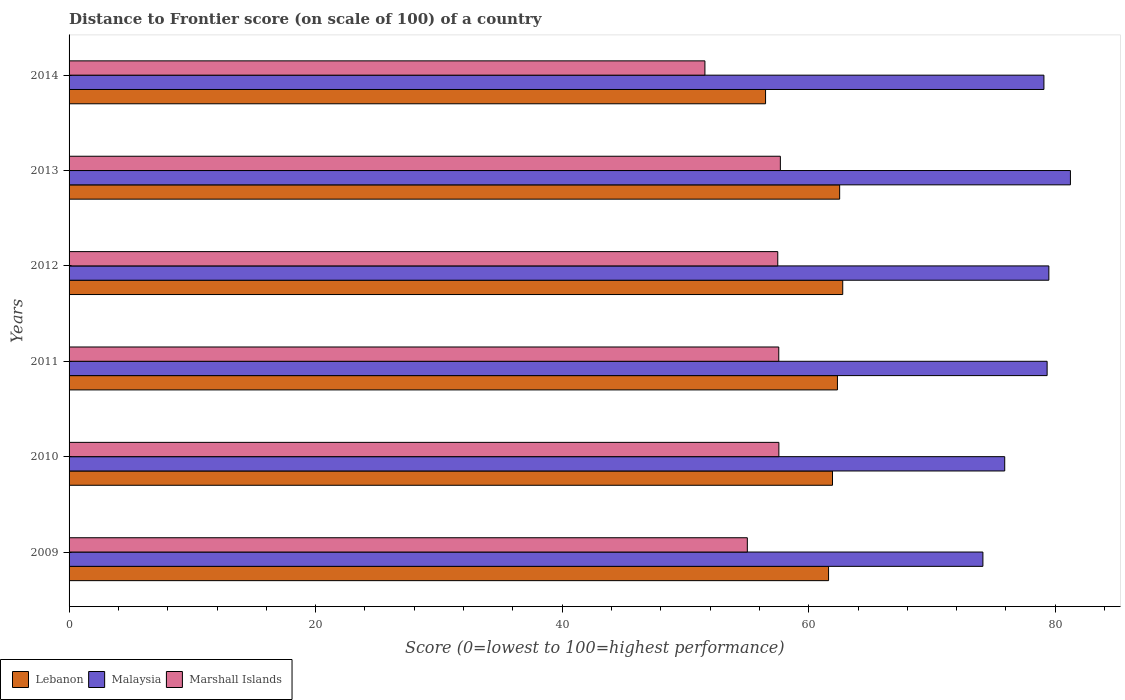How many different coloured bars are there?
Provide a short and direct response. 3. How many groups of bars are there?
Your answer should be compact. 6. Are the number of bars on each tick of the Y-axis equal?
Give a very brief answer. Yes. How many bars are there on the 3rd tick from the top?
Make the answer very short. 3. How many bars are there on the 6th tick from the bottom?
Keep it short and to the point. 3. In how many cases, is the number of bars for a given year not equal to the number of legend labels?
Provide a succinct answer. 0. What is the distance to frontier score of in Lebanon in 2011?
Your response must be concise. 62.33. Across all years, what is the maximum distance to frontier score of in Lebanon?
Offer a very short reply. 62.76. Across all years, what is the minimum distance to frontier score of in Marshall Islands?
Your answer should be very brief. 51.58. In which year was the distance to frontier score of in Malaysia maximum?
Make the answer very short. 2013. What is the total distance to frontier score of in Marshall Islands in the graph?
Provide a short and direct response. 336.94. What is the difference between the distance to frontier score of in Marshall Islands in 2009 and that in 2010?
Provide a short and direct response. -2.56. What is the difference between the distance to frontier score of in Lebanon in 2010 and the distance to frontier score of in Marshall Islands in 2011?
Offer a terse response. 4.36. What is the average distance to frontier score of in Marshall Islands per year?
Make the answer very short. 56.16. In the year 2011, what is the difference between the distance to frontier score of in Lebanon and distance to frontier score of in Malaysia?
Your answer should be compact. -17.01. What is the ratio of the distance to frontier score of in Marshall Islands in 2013 to that in 2014?
Provide a succinct answer. 1.12. Is the distance to frontier score of in Marshall Islands in 2009 less than that in 2010?
Give a very brief answer. Yes. What is the difference between the highest and the lowest distance to frontier score of in Malaysia?
Make the answer very short. 7.1. Is the sum of the distance to frontier score of in Marshall Islands in 2011 and 2013 greater than the maximum distance to frontier score of in Malaysia across all years?
Offer a terse response. Yes. What does the 3rd bar from the top in 2009 represents?
Offer a terse response. Lebanon. What does the 1st bar from the bottom in 2010 represents?
Offer a terse response. Lebanon. How many bars are there?
Provide a short and direct response. 18. Are all the bars in the graph horizontal?
Give a very brief answer. Yes. What is the difference between two consecutive major ticks on the X-axis?
Offer a very short reply. 20. Are the values on the major ticks of X-axis written in scientific E-notation?
Your response must be concise. No. Does the graph contain any zero values?
Ensure brevity in your answer.  No. Does the graph contain grids?
Ensure brevity in your answer.  No. How are the legend labels stacked?
Ensure brevity in your answer.  Horizontal. What is the title of the graph?
Ensure brevity in your answer.  Distance to Frontier score (on scale of 100) of a country. Does "St. Lucia" appear as one of the legend labels in the graph?
Your answer should be compact. No. What is the label or title of the X-axis?
Make the answer very short. Score (0=lowest to 100=highest performance). What is the label or title of the Y-axis?
Provide a succinct answer. Years. What is the Score (0=lowest to 100=highest performance) of Lebanon in 2009?
Give a very brief answer. 61.61. What is the Score (0=lowest to 100=highest performance) in Malaysia in 2009?
Your answer should be compact. 74.13. What is the Score (0=lowest to 100=highest performance) in Marshall Islands in 2009?
Your answer should be compact. 55.02. What is the Score (0=lowest to 100=highest performance) in Lebanon in 2010?
Your response must be concise. 61.93. What is the Score (0=lowest to 100=highest performance) of Malaysia in 2010?
Your answer should be very brief. 75.9. What is the Score (0=lowest to 100=highest performance) of Marshall Islands in 2010?
Keep it short and to the point. 57.58. What is the Score (0=lowest to 100=highest performance) of Lebanon in 2011?
Make the answer very short. 62.33. What is the Score (0=lowest to 100=highest performance) of Malaysia in 2011?
Your answer should be compact. 79.34. What is the Score (0=lowest to 100=highest performance) in Marshall Islands in 2011?
Ensure brevity in your answer.  57.57. What is the Score (0=lowest to 100=highest performance) in Lebanon in 2012?
Your response must be concise. 62.76. What is the Score (0=lowest to 100=highest performance) of Malaysia in 2012?
Keep it short and to the point. 79.48. What is the Score (0=lowest to 100=highest performance) in Marshall Islands in 2012?
Make the answer very short. 57.49. What is the Score (0=lowest to 100=highest performance) in Lebanon in 2013?
Your response must be concise. 62.51. What is the Score (0=lowest to 100=highest performance) in Malaysia in 2013?
Provide a succinct answer. 81.23. What is the Score (0=lowest to 100=highest performance) of Marshall Islands in 2013?
Your answer should be compact. 57.7. What is the Score (0=lowest to 100=highest performance) in Lebanon in 2014?
Make the answer very short. 56.5. What is the Score (0=lowest to 100=highest performance) in Malaysia in 2014?
Offer a terse response. 79.08. What is the Score (0=lowest to 100=highest performance) of Marshall Islands in 2014?
Your response must be concise. 51.58. Across all years, what is the maximum Score (0=lowest to 100=highest performance) of Lebanon?
Give a very brief answer. 62.76. Across all years, what is the maximum Score (0=lowest to 100=highest performance) of Malaysia?
Provide a succinct answer. 81.23. Across all years, what is the maximum Score (0=lowest to 100=highest performance) in Marshall Islands?
Provide a short and direct response. 57.7. Across all years, what is the minimum Score (0=lowest to 100=highest performance) in Lebanon?
Make the answer very short. 56.5. Across all years, what is the minimum Score (0=lowest to 100=highest performance) in Malaysia?
Keep it short and to the point. 74.13. Across all years, what is the minimum Score (0=lowest to 100=highest performance) in Marshall Islands?
Offer a very short reply. 51.58. What is the total Score (0=lowest to 100=highest performance) of Lebanon in the graph?
Give a very brief answer. 367.64. What is the total Score (0=lowest to 100=highest performance) in Malaysia in the graph?
Keep it short and to the point. 469.16. What is the total Score (0=lowest to 100=highest performance) in Marshall Islands in the graph?
Offer a very short reply. 336.94. What is the difference between the Score (0=lowest to 100=highest performance) of Lebanon in 2009 and that in 2010?
Ensure brevity in your answer.  -0.32. What is the difference between the Score (0=lowest to 100=highest performance) of Malaysia in 2009 and that in 2010?
Ensure brevity in your answer.  -1.77. What is the difference between the Score (0=lowest to 100=highest performance) in Marshall Islands in 2009 and that in 2010?
Ensure brevity in your answer.  -2.56. What is the difference between the Score (0=lowest to 100=highest performance) of Lebanon in 2009 and that in 2011?
Ensure brevity in your answer.  -0.72. What is the difference between the Score (0=lowest to 100=highest performance) in Malaysia in 2009 and that in 2011?
Ensure brevity in your answer.  -5.21. What is the difference between the Score (0=lowest to 100=highest performance) in Marshall Islands in 2009 and that in 2011?
Keep it short and to the point. -2.55. What is the difference between the Score (0=lowest to 100=highest performance) of Lebanon in 2009 and that in 2012?
Provide a short and direct response. -1.15. What is the difference between the Score (0=lowest to 100=highest performance) of Malaysia in 2009 and that in 2012?
Give a very brief answer. -5.35. What is the difference between the Score (0=lowest to 100=highest performance) in Marshall Islands in 2009 and that in 2012?
Offer a very short reply. -2.47. What is the difference between the Score (0=lowest to 100=highest performance) of Lebanon in 2009 and that in 2013?
Offer a very short reply. -0.9. What is the difference between the Score (0=lowest to 100=highest performance) of Marshall Islands in 2009 and that in 2013?
Offer a terse response. -2.68. What is the difference between the Score (0=lowest to 100=highest performance) of Lebanon in 2009 and that in 2014?
Provide a short and direct response. 5.11. What is the difference between the Score (0=lowest to 100=highest performance) of Malaysia in 2009 and that in 2014?
Make the answer very short. -4.95. What is the difference between the Score (0=lowest to 100=highest performance) of Marshall Islands in 2009 and that in 2014?
Your response must be concise. 3.44. What is the difference between the Score (0=lowest to 100=highest performance) of Malaysia in 2010 and that in 2011?
Provide a short and direct response. -3.44. What is the difference between the Score (0=lowest to 100=highest performance) of Marshall Islands in 2010 and that in 2011?
Your response must be concise. 0.01. What is the difference between the Score (0=lowest to 100=highest performance) in Lebanon in 2010 and that in 2012?
Offer a terse response. -0.83. What is the difference between the Score (0=lowest to 100=highest performance) in Malaysia in 2010 and that in 2012?
Give a very brief answer. -3.58. What is the difference between the Score (0=lowest to 100=highest performance) of Marshall Islands in 2010 and that in 2012?
Your answer should be very brief. 0.09. What is the difference between the Score (0=lowest to 100=highest performance) in Lebanon in 2010 and that in 2013?
Offer a terse response. -0.58. What is the difference between the Score (0=lowest to 100=highest performance) in Malaysia in 2010 and that in 2013?
Provide a succinct answer. -5.33. What is the difference between the Score (0=lowest to 100=highest performance) of Marshall Islands in 2010 and that in 2013?
Your answer should be compact. -0.12. What is the difference between the Score (0=lowest to 100=highest performance) in Lebanon in 2010 and that in 2014?
Provide a short and direct response. 5.43. What is the difference between the Score (0=lowest to 100=highest performance) in Malaysia in 2010 and that in 2014?
Provide a short and direct response. -3.18. What is the difference between the Score (0=lowest to 100=highest performance) in Marshall Islands in 2010 and that in 2014?
Provide a succinct answer. 6. What is the difference between the Score (0=lowest to 100=highest performance) in Lebanon in 2011 and that in 2012?
Offer a terse response. -0.43. What is the difference between the Score (0=lowest to 100=highest performance) of Malaysia in 2011 and that in 2012?
Your answer should be very brief. -0.14. What is the difference between the Score (0=lowest to 100=highest performance) in Marshall Islands in 2011 and that in 2012?
Your answer should be very brief. 0.08. What is the difference between the Score (0=lowest to 100=highest performance) of Lebanon in 2011 and that in 2013?
Your answer should be compact. -0.18. What is the difference between the Score (0=lowest to 100=highest performance) in Malaysia in 2011 and that in 2013?
Your answer should be very brief. -1.89. What is the difference between the Score (0=lowest to 100=highest performance) in Marshall Islands in 2011 and that in 2013?
Give a very brief answer. -0.13. What is the difference between the Score (0=lowest to 100=highest performance) in Lebanon in 2011 and that in 2014?
Give a very brief answer. 5.83. What is the difference between the Score (0=lowest to 100=highest performance) of Malaysia in 2011 and that in 2014?
Make the answer very short. 0.26. What is the difference between the Score (0=lowest to 100=highest performance) in Marshall Islands in 2011 and that in 2014?
Your answer should be compact. 5.99. What is the difference between the Score (0=lowest to 100=highest performance) in Lebanon in 2012 and that in 2013?
Keep it short and to the point. 0.25. What is the difference between the Score (0=lowest to 100=highest performance) of Malaysia in 2012 and that in 2013?
Provide a succinct answer. -1.75. What is the difference between the Score (0=lowest to 100=highest performance) of Marshall Islands in 2012 and that in 2013?
Your response must be concise. -0.21. What is the difference between the Score (0=lowest to 100=highest performance) of Lebanon in 2012 and that in 2014?
Provide a short and direct response. 6.26. What is the difference between the Score (0=lowest to 100=highest performance) of Marshall Islands in 2012 and that in 2014?
Your answer should be compact. 5.91. What is the difference between the Score (0=lowest to 100=highest performance) of Lebanon in 2013 and that in 2014?
Provide a succinct answer. 6.01. What is the difference between the Score (0=lowest to 100=highest performance) in Malaysia in 2013 and that in 2014?
Give a very brief answer. 2.15. What is the difference between the Score (0=lowest to 100=highest performance) in Marshall Islands in 2013 and that in 2014?
Offer a terse response. 6.12. What is the difference between the Score (0=lowest to 100=highest performance) in Lebanon in 2009 and the Score (0=lowest to 100=highest performance) in Malaysia in 2010?
Offer a terse response. -14.29. What is the difference between the Score (0=lowest to 100=highest performance) of Lebanon in 2009 and the Score (0=lowest to 100=highest performance) of Marshall Islands in 2010?
Ensure brevity in your answer.  4.03. What is the difference between the Score (0=lowest to 100=highest performance) of Malaysia in 2009 and the Score (0=lowest to 100=highest performance) of Marshall Islands in 2010?
Provide a succinct answer. 16.55. What is the difference between the Score (0=lowest to 100=highest performance) in Lebanon in 2009 and the Score (0=lowest to 100=highest performance) in Malaysia in 2011?
Your answer should be very brief. -17.73. What is the difference between the Score (0=lowest to 100=highest performance) in Lebanon in 2009 and the Score (0=lowest to 100=highest performance) in Marshall Islands in 2011?
Give a very brief answer. 4.04. What is the difference between the Score (0=lowest to 100=highest performance) of Malaysia in 2009 and the Score (0=lowest to 100=highest performance) of Marshall Islands in 2011?
Provide a succinct answer. 16.56. What is the difference between the Score (0=lowest to 100=highest performance) of Lebanon in 2009 and the Score (0=lowest to 100=highest performance) of Malaysia in 2012?
Keep it short and to the point. -17.87. What is the difference between the Score (0=lowest to 100=highest performance) of Lebanon in 2009 and the Score (0=lowest to 100=highest performance) of Marshall Islands in 2012?
Ensure brevity in your answer.  4.12. What is the difference between the Score (0=lowest to 100=highest performance) in Malaysia in 2009 and the Score (0=lowest to 100=highest performance) in Marshall Islands in 2012?
Offer a very short reply. 16.64. What is the difference between the Score (0=lowest to 100=highest performance) of Lebanon in 2009 and the Score (0=lowest to 100=highest performance) of Malaysia in 2013?
Your response must be concise. -19.62. What is the difference between the Score (0=lowest to 100=highest performance) of Lebanon in 2009 and the Score (0=lowest to 100=highest performance) of Marshall Islands in 2013?
Your answer should be very brief. 3.91. What is the difference between the Score (0=lowest to 100=highest performance) of Malaysia in 2009 and the Score (0=lowest to 100=highest performance) of Marshall Islands in 2013?
Your answer should be compact. 16.43. What is the difference between the Score (0=lowest to 100=highest performance) in Lebanon in 2009 and the Score (0=lowest to 100=highest performance) in Malaysia in 2014?
Offer a terse response. -17.47. What is the difference between the Score (0=lowest to 100=highest performance) in Lebanon in 2009 and the Score (0=lowest to 100=highest performance) in Marshall Islands in 2014?
Provide a succinct answer. 10.03. What is the difference between the Score (0=lowest to 100=highest performance) of Malaysia in 2009 and the Score (0=lowest to 100=highest performance) of Marshall Islands in 2014?
Your response must be concise. 22.55. What is the difference between the Score (0=lowest to 100=highest performance) in Lebanon in 2010 and the Score (0=lowest to 100=highest performance) in Malaysia in 2011?
Your answer should be very brief. -17.41. What is the difference between the Score (0=lowest to 100=highest performance) in Lebanon in 2010 and the Score (0=lowest to 100=highest performance) in Marshall Islands in 2011?
Provide a succinct answer. 4.36. What is the difference between the Score (0=lowest to 100=highest performance) of Malaysia in 2010 and the Score (0=lowest to 100=highest performance) of Marshall Islands in 2011?
Your response must be concise. 18.33. What is the difference between the Score (0=lowest to 100=highest performance) of Lebanon in 2010 and the Score (0=lowest to 100=highest performance) of Malaysia in 2012?
Provide a short and direct response. -17.55. What is the difference between the Score (0=lowest to 100=highest performance) of Lebanon in 2010 and the Score (0=lowest to 100=highest performance) of Marshall Islands in 2012?
Offer a very short reply. 4.44. What is the difference between the Score (0=lowest to 100=highest performance) of Malaysia in 2010 and the Score (0=lowest to 100=highest performance) of Marshall Islands in 2012?
Keep it short and to the point. 18.41. What is the difference between the Score (0=lowest to 100=highest performance) of Lebanon in 2010 and the Score (0=lowest to 100=highest performance) of Malaysia in 2013?
Your answer should be compact. -19.3. What is the difference between the Score (0=lowest to 100=highest performance) in Lebanon in 2010 and the Score (0=lowest to 100=highest performance) in Marshall Islands in 2013?
Provide a succinct answer. 4.23. What is the difference between the Score (0=lowest to 100=highest performance) in Malaysia in 2010 and the Score (0=lowest to 100=highest performance) in Marshall Islands in 2013?
Provide a succinct answer. 18.2. What is the difference between the Score (0=lowest to 100=highest performance) of Lebanon in 2010 and the Score (0=lowest to 100=highest performance) of Malaysia in 2014?
Your answer should be very brief. -17.15. What is the difference between the Score (0=lowest to 100=highest performance) of Lebanon in 2010 and the Score (0=lowest to 100=highest performance) of Marshall Islands in 2014?
Offer a terse response. 10.35. What is the difference between the Score (0=lowest to 100=highest performance) of Malaysia in 2010 and the Score (0=lowest to 100=highest performance) of Marshall Islands in 2014?
Provide a short and direct response. 24.32. What is the difference between the Score (0=lowest to 100=highest performance) of Lebanon in 2011 and the Score (0=lowest to 100=highest performance) of Malaysia in 2012?
Your answer should be compact. -17.15. What is the difference between the Score (0=lowest to 100=highest performance) of Lebanon in 2011 and the Score (0=lowest to 100=highest performance) of Marshall Islands in 2012?
Ensure brevity in your answer.  4.84. What is the difference between the Score (0=lowest to 100=highest performance) of Malaysia in 2011 and the Score (0=lowest to 100=highest performance) of Marshall Islands in 2012?
Offer a very short reply. 21.85. What is the difference between the Score (0=lowest to 100=highest performance) in Lebanon in 2011 and the Score (0=lowest to 100=highest performance) in Malaysia in 2013?
Your answer should be very brief. -18.9. What is the difference between the Score (0=lowest to 100=highest performance) of Lebanon in 2011 and the Score (0=lowest to 100=highest performance) of Marshall Islands in 2013?
Make the answer very short. 4.63. What is the difference between the Score (0=lowest to 100=highest performance) in Malaysia in 2011 and the Score (0=lowest to 100=highest performance) in Marshall Islands in 2013?
Your answer should be compact. 21.64. What is the difference between the Score (0=lowest to 100=highest performance) in Lebanon in 2011 and the Score (0=lowest to 100=highest performance) in Malaysia in 2014?
Offer a very short reply. -16.75. What is the difference between the Score (0=lowest to 100=highest performance) in Lebanon in 2011 and the Score (0=lowest to 100=highest performance) in Marshall Islands in 2014?
Make the answer very short. 10.75. What is the difference between the Score (0=lowest to 100=highest performance) of Malaysia in 2011 and the Score (0=lowest to 100=highest performance) of Marshall Islands in 2014?
Offer a very short reply. 27.76. What is the difference between the Score (0=lowest to 100=highest performance) in Lebanon in 2012 and the Score (0=lowest to 100=highest performance) in Malaysia in 2013?
Your response must be concise. -18.47. What is the difference between the Score (0=lowest to 100=highest performance) of Lebanon in 2012 and the Score (0=lowest to 100=highest performance) of Marshall Islands in 2013?
Make the answer very short. 5.06. What is the difference between the Score (0=lowest to 100=highest performance) of Malaysia in 2012 and the Score (0=lowest to 100=highest performance) of Marshall Islands in 2013?
Give a very brief answer. 21.78. What is the difference between the Score (0=lowest to 100=highest performance) of Lebanon in 2012 and the Score (0=lowest to 100=highest performance) of Malaysia in 2014?
Ensure brevity in your answer.  -16.32. What is the difference between the Score (0=lowest to 100=highest performance) of Lebanon in 2012 and the Score (0=lowest to 100=highest performance) of Marshall Islands in 2014?
Provide a succinct answer. 11.18. What is the difference between the Score (0=lowest to 100=highest performance) in Malaysia in 2012 and the Score (0=lowest to 100=highest performance) in Marshall Islands in 2014?
Provide a succinct answer. 27.9. What is the difference between the Score (0=lowest to 100=highest performance) of Lebanon in 2013 and the Score (0=lowest to 100=highest performance) of Malaysia in 2014?
Your answer should be very brief. -16.57. What is the difference between the Score (0=lowest to 100=highest performance) of Lebanon in 2013 and the Score (0=lowest to 100=highest performance) of Marshall Islands in 2014?
Your answer should be compact. 10.93. What is the difference between the Score (0=lowest to 100=highest performance) of Malaysia in 2013 and the Score (0=lowest to 100=highest performance) of Marshall Islands in 2014?
Give a very brief answer. 29.65. What is the average Score (0=lowest to 100=highest performance) in Lebanon per year?
Keep it short and to the point. 61.27. What is the average Score (0=lowest to 100=highest performance) of Malaysia per year?
Offer a terse response. 78.19. What is the average Score (0=lowest to 100=highest performance) in Marshall Islands per year?
Give a very brief answer. 56.16. In the year 2009, what is the difference between the Score (0=lowest to 100=highest performance) in Lebanon and Score (0=lowest to 100=highest performance) in Malaysia?
Provide a succinct answer. -12.52. In the year 2009, what is the difference between the Score (0=lowest to 100=highest performance) of Lebanon and Score (0=lowest to 100=highest performance) of Marshall Islands?
Keep it short and to the point. 6.59. In the year 2009, what is the difference between the Score (0=lowest to 100=highest performance) in Malaysia and Score (0=lowest to 100=highest performance) in Marshall Islands?
Your answer should be very brief. 19.11. In the year 2010, what is the difference between the Score (0=lowest to 100=highest performance) of Lebanon and Score (0=lowest to 100=highest performance) of Malaysia?
Offer a terse response. -13.97. In the year 2010, what is the difference between the Score (0=lowest to 100=highest performance) in Lebanon and Score (0=lowest to 100=highest performance) in Marshall Islands?
Give a very brief answer. 4.35. In the year 2010, what is the difference between the Score (0=lowest to 100=highest performance) in Malaysia and Score (0=lowest to 100=highest performance) in Marshall Islands?
Offer a terse response. 18.32. In the year 2011, what is the difference between the Score (0=lowest to 100=highest performance) of Lebanon and Score (0=lowest to 100=highest performance) of Malaysia?
Ensure brevity in your answer.  -17.01. In the year 2011, what is the difference between the Score (0=lowest to 100=highest performance) in Lebanon and Score (0=lowest to 100=highest performance) in Marshall Islands?
Offer a terse response. 4.76. In the year 2011, what is the difference between the Score (0=lowest to 100=highest performance) in Malaysia and Score (0=lowest to 100=highest performance) in Marshall Islands?
Your answer should be very brief. 21.77. In the year 2012, what is the difference between the Score (0=lowest to 100=highest performance) of Lebanon and Score (0=lowest to 100=highest performance) of Malaysia?
Keep it short and to the point. -16.72. In the year 2012, what is the difference between the Score (0=lowest to 100=highest performance) in Lebanon and Score (0=lowest to 100=highest performance) in Marshall Islands?
Offer a terse response. 5.27. In the year 2012, what is the difference between the Score (0=lowest to 100=highest performance) in Malaysia and Score (0=lowest to 100=highest performance) in Marshall Islands?
Your response must be concise. 21.99. In the year 2013, what is the difference between the Score (0=lowest to 100=highest performance) in Lebanon and Score (0=lowest to 100=highest performance) in Malaysia?
Give a very brief answer. -18.72. In the year 2013, what is the difference between the Score (0=lowest to 100=highest performance) in Lebanon and Score (0=lowest to 100=highest performance) in Marshall Islands?
Your response must be concise. 4.81. In the year 2013, what is the difference between the Score (0=lowest to 100=highest performance) in Malaysia and Score (0=lowest to 100=highest performance) in Marshall Islands?
Ensure brevity in your answer.  23.53. In the year 2014, what is the difference between the Score (0=lowest to 100=highest performance) of Lebanon and Score (0=lowest to 100=highest performance) of Malaysia?
Make the answer very short. -22.58. In the year 2014, what is the difference between the Score (0=lowest to 100=highest performance) of Lebanon and Score (0=lowest to 100=highest performance) of Marshall Islands?
Your response must be concise. 4.92. What is the ratio of the Score (0=lowest to 100=highest performance) in Lebanon in 2009 to that in 2010?
Your response must be concise. 0.99. What is the ratio of the Score (0=lowest to 100=highest performance) in Malaysia in 2009 to that in 2010?
Your response must be concise. 0.98. What is the ratio of the Score (0=lowest to 100=highest performance) in Marshall Islands in 2009 to that in 2010?
Provide a short and direct response. 0.96. What is the ratio of the Score (0=lowest to 100=highest performance) of Lebanon in 2009 to that in 2011?
Your answer should be very brief. 0.99. What is the ratio of the Score (0=lowest to 100=highest performance) in Malaysia in 2009 to that in 2011?
Keep it short and to the point. 0.93. What is the ratio of the Score (0=lowest to 100=highest performance) of Marshall Islands in 2009 to that in 2011?
Your response must be concise. 0.96. What is the ratio of the Score (0=lowest to 100=highest performance) in Lebanon in 2009 to that in 2012?
Your answer should be very brief. 0.98. What is the ratio of the Score (0=lowest to 100=highest performance) in Malaysia in 2009 to that in 2012?
Ensure brevity in your answer.  0.93. What is the ratio of the Score (0=lowest to 100=highest performance) of Marshall Islands in 2009 to that in 2012?
Provide a short and direct response. 0.96. What is the ratio of the Score (0=lowest to 100=highest performance) of Lebanon in 2009 to that in 2013?
Your answer should be compact. 0.99. What is the ratio of the Score (0=lowest to 100=highest performance) in Malaysia in 2009 to that in 2013?
Keep it short and to the point. 0.91. What is the ratio of the Score (0=lowest to 100=highest performance) of Marshall Islands in 2009 to that in 2013?
Make the answer very short. 0.95. What is the ratio of the Score (0=lowest to 100=highest performance) of Lebanon in 2009 to that in 2014?
Provide a short and direct response. 1.09. What is the ratio of the Score (0=lowest to 100=highest performance) in Malaysia in 2009 to that in 2014?
Keep it short and to the point. 0.94. What is the ratio of the Score (0=lowest to 100=highest performance) in Marshall Islands in 2009 to that in 2014?
Ensure brevity in your answer.  1.07. What is the ratio of the Score (0=lowest to 100=highest performance) in Malaysia in 2010 to that in 2011?
Your answer should be very brief. 0.96. What is the ratio of the Score (0=lowest to 100=highest performance) in Malaysia in 2010 to that in 2012?
Offer a terse response. 0.95. What is the ratio of the Score (0=lowest to 100=highest performance) in Malaysia in 2010 to that in 2013?
Offer a terse response. 0.93. What is the ratio of the Score (0=lowest to 100=highest performance) in Marshall Islands in 2010 to that in 2013?
Your response must be concise. 1. What is the ratio of the Score (0=lowest to 100=highest performance) in Lebanon in 2010 to that in 2014?
Make the answer very short. 1.1. What is the ratio of the Score (0=lowest to 100=highest performance) of Malaysia in 2010 to that in 2014?
Your response must be concise. 0.96. What is the ratio of the Score (0=lowest to 100=highest performance) of Marshall Islands in 2010 to that in 2014?
Keep it short and to the point. 1.12. What is the ratio of the Score (0=lowest to 100=highest performance) in Lebanon in 2011 to that in 2012?
Give a very brief answer. 0.99. What is the ratio of the Score (0=lowest to 100=highest performance) in Malaysia in 2011 to that in 2013?
Your response must be concise. 0.98. What is the ratio of the Score (0=lowest to 100=highest performance) of Marshall Islands in 2011 to that in 2013?
Offer a terse response. 1. What is the ratio of the Score (0=lowest to 100=highest performance) of Lebanon in 2011 to that in 2014?
Make the answer very short. 1.1. What is the ratio of the Score (0=lowest to 100=highest performance) of Marshall Islands in 2011 to that in 2014?
Your answer should be compact. 1.12. What is the ratio of the Score (0=lowest to 100=highest performance) of Lebanon in 2012 to that in 2013?
Your response must be concise. 1. What is the ratio of the Score (0=lowest to 100=highest performance) in Malaysia in 2012 to that in 2013?
Keep it short and to the point. 0.98. What is the ratio of the Score (0=lowest to 100=highest performance) in Lebanon in 2012 to that in 2014?
Offer a terse response. 1.11. What is the ratio of the Score (0=lowest to 100=highest performance) in Marshall Islands in 2012 to that in 2014?
Ensure brevity in your answer.  1.11. What is the ratio of the Score (0=lowest to 100=highest performance) of Lebanon in 2013 to that in 2014?
Your response must be concise. 1.11. What is the ratio of the Score (0=lowest to 100=highest performance) in Malaysia in 2013 to that in 2014?
Make the answer very short. 1.03. What is the ratio of the Score (0=lowest to 100=highest performance) of Marshall Islands in 2013 to that in 2014?
Offer a very short reply. 1.12. What is the difference between the highest and the second highest Score (0=lowest to 100=highest performance) of Malaysia?
Make the answer very short. 1.75. What is the difference between the highest and the second highest Score (0=lowest to 100=highest performance) in Marshall Islands?
Your answer should be compact. 0.12. What is the difference between the highest and the lowest Score (0=lowest to 100=highest performance) in Lebanon?
Offer a very short reply. 6.26. What is the difference between the highest and the lowest Score (0=lowest to 100=highest performance) in Marshall Islands?
Keep it short and to the point. 6.12. 